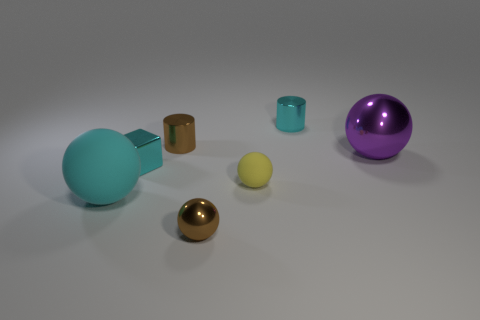Are there more metallic spheres behind the tiny rubber object than tiny brown spheres to the left of the tiny brown sphere?
Keep it short and to the point. Yes. How many tiny cylinders are left of the tiny brown metal object that is in front of the big cyan ball?
Offer a terse response. 1. How many objects are either spheres or tiny rubber objects?
Your response must be concise. 4. Do the small yellow object and the purple object have the same shape?
Provide a succinct answer. Yes. What is the cyan cylinder made of?
Keep it short and to the point. Metal. How many rubber objects are both left of the cyan metallic cube and behind the cyan rubber thing?
Your answer should be compact. 0. Is the size of the yellow rubber sphere the same as the purple metallic object?
Make the answer very short. No. Do the cyan metal object behind the block and the brown metallic cylinder have the same size?
Provide a short and direct response. Yes. The rubber ball that is on the right side of the metallic block is what color?
Your answer should be very brief. Yellow. How many small cyan metallic cylinders are there?
Make the answer very short. 1. 